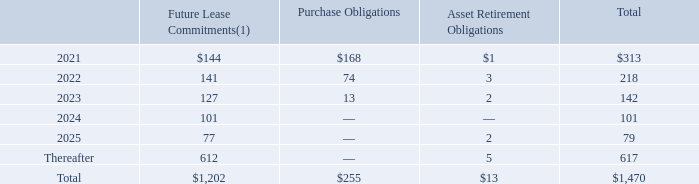Operating Leases and Other Contractual Commitments
VMware leases office facilities and equipment under various operating arrangements. VMware’s minimum future lease commitments and other contractual commitments at January 31, 2020 were as follows (table in millions):
(1) Amounts in the table above exclude legally binding minimum lease payments for leases signed but not yet commenced of $361 million, as well as expected sublease income.
The amount of the future lease commitments after fiscal 2025 is primarily for the ground leases on VMware’s Palo Alto, California headquarter facilities, which expire in fiscal 2047. As several of VMware’s operating leases are payable in foreign currencies, the operating lease payments may fluctuate in response to changes in the exchange rate between the U.S. dollar and the foreign currencies in which the commitments are payable.
What does the amount for future lease commitments exclude? Legally binding minimum lease payments for leases signed but not yet commenced of $361 million, as well as expected sublease income. What were the purchase obligations in 2022?
Answer scale should be: million. 74. What were the Asset Retirement Obligations in 2023?
Answer scale should be: million. 2. What was the change in future lease commitments between 2021 and 2022?
Answer scale should be: million. 141-144
Answer: -3. What was the change in total contractual obligations between 2023 and 2022?
Answer scale should be: million. 142-218
Answer: -76. What was the percentage change in purchase obligations between 2022 and 2023?
Answer scale should be: percent. (13-74)/74
Answer: -82.43. 